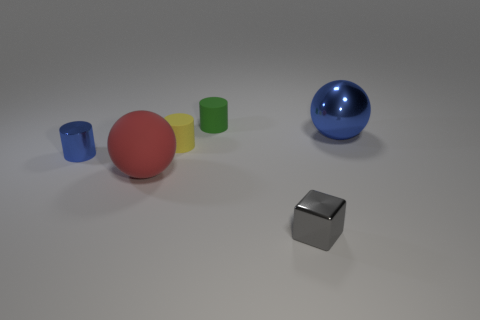Do the blue thing that is left of the yellow cylinder and the green object have the same material?
Ensure brevity in your answer.  No. What is the material of the other red ball that is the same size as the shiny ball?
Ensure brevity in your answer.  Rubber. What number of other objects are there of the same material as the yellow cylinder?
Offer a terse response. 2. There is a metallic cylinder; does it have the same size as the sphere on the left side of the gray object?
Keep it short and to the point. No. Are there an equal number of purple cylinders and small metallic cylinders?
Your answer should be compact. No. Is the number of red matte spheres right of the large red rubber ball less than the number of tiny gray metallic objects on the right side of the blue cylinder?
Make the answer very short. Yes. There is a shiny thing that is to the left of the tiny gray metallic block; what is its size?
Your answer should be very brief. Small. Does the green thing have the same size as the shiny ball?
Offer a terse response. No. What number of things are both to the right of the small green matte thing and behind the block?
Your answer should be very brief. 1. How many blue things are either matte objects or big objects?
Your response must be concise. 1. 